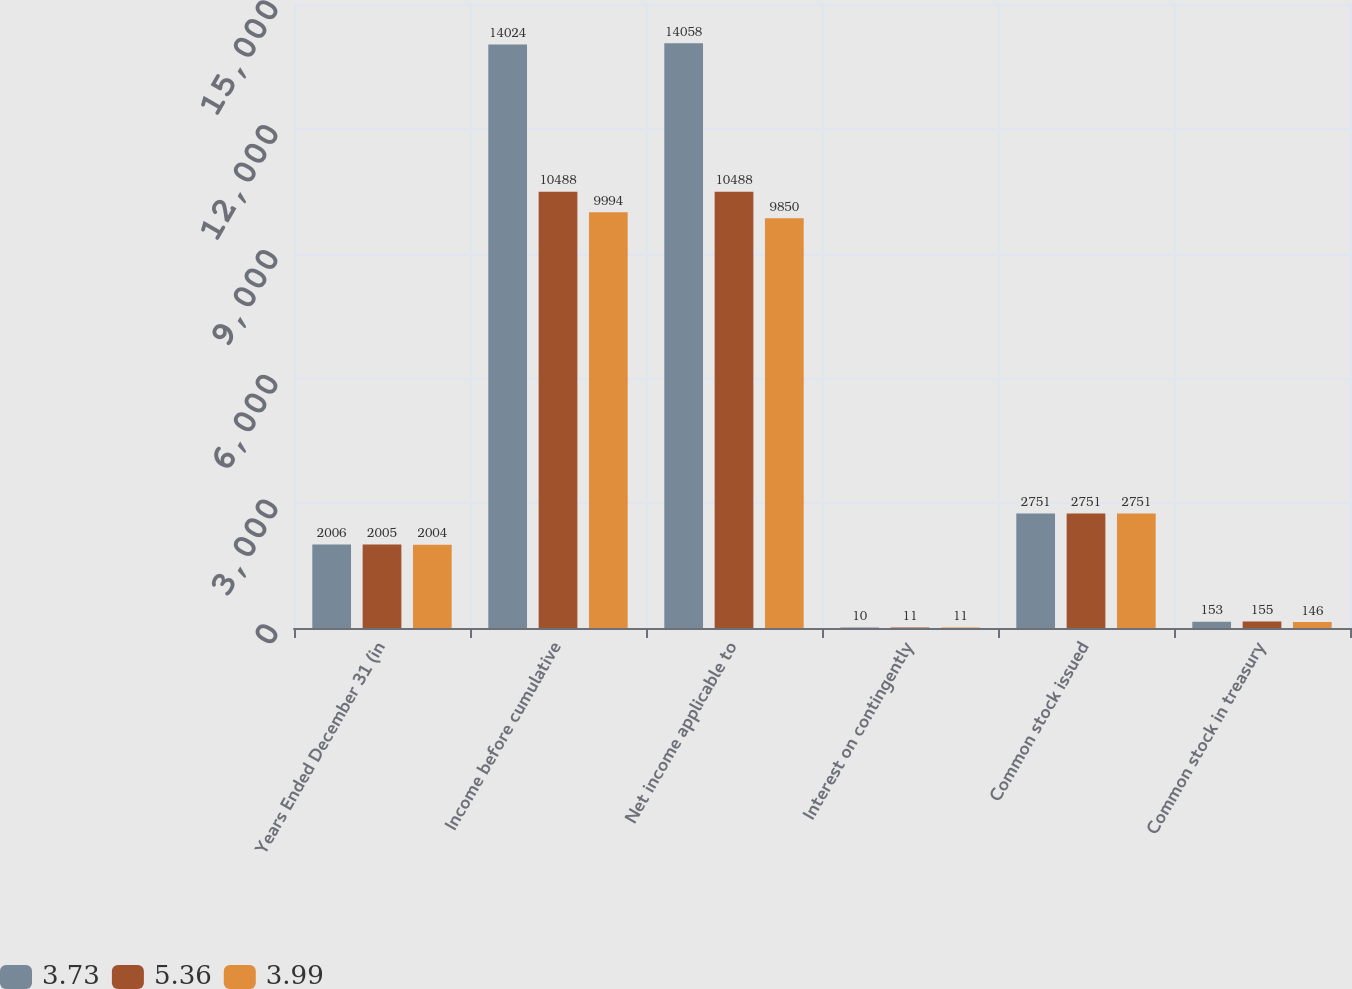Convert chart to OTSL. <chart><loc_0><loc_0><loc_500><loc_500><stacked_bar_chart><ecel><fcel>Years Ended December 31 (in<fcel>Income before cumulative<fcel>Net income applicable to<fcel>Interest on contingently<fcel>Common stock issued<fcel>Common stock in treasury<nl><fcel>3.73<fcel>2006<fcel>14024<fcel>14058<fcel>10<fcel>2751<fcel>153<nl><fcel>5.36<fcel>2005<fcel>10488<fcel>10488<fcel>11<fcel>2751<fcel>155<nl><fcel>3.99<fcel>2004<fcel>9994<fcel>9850<fcel>11<fcel>2751<fcel>146<nl></chart> 